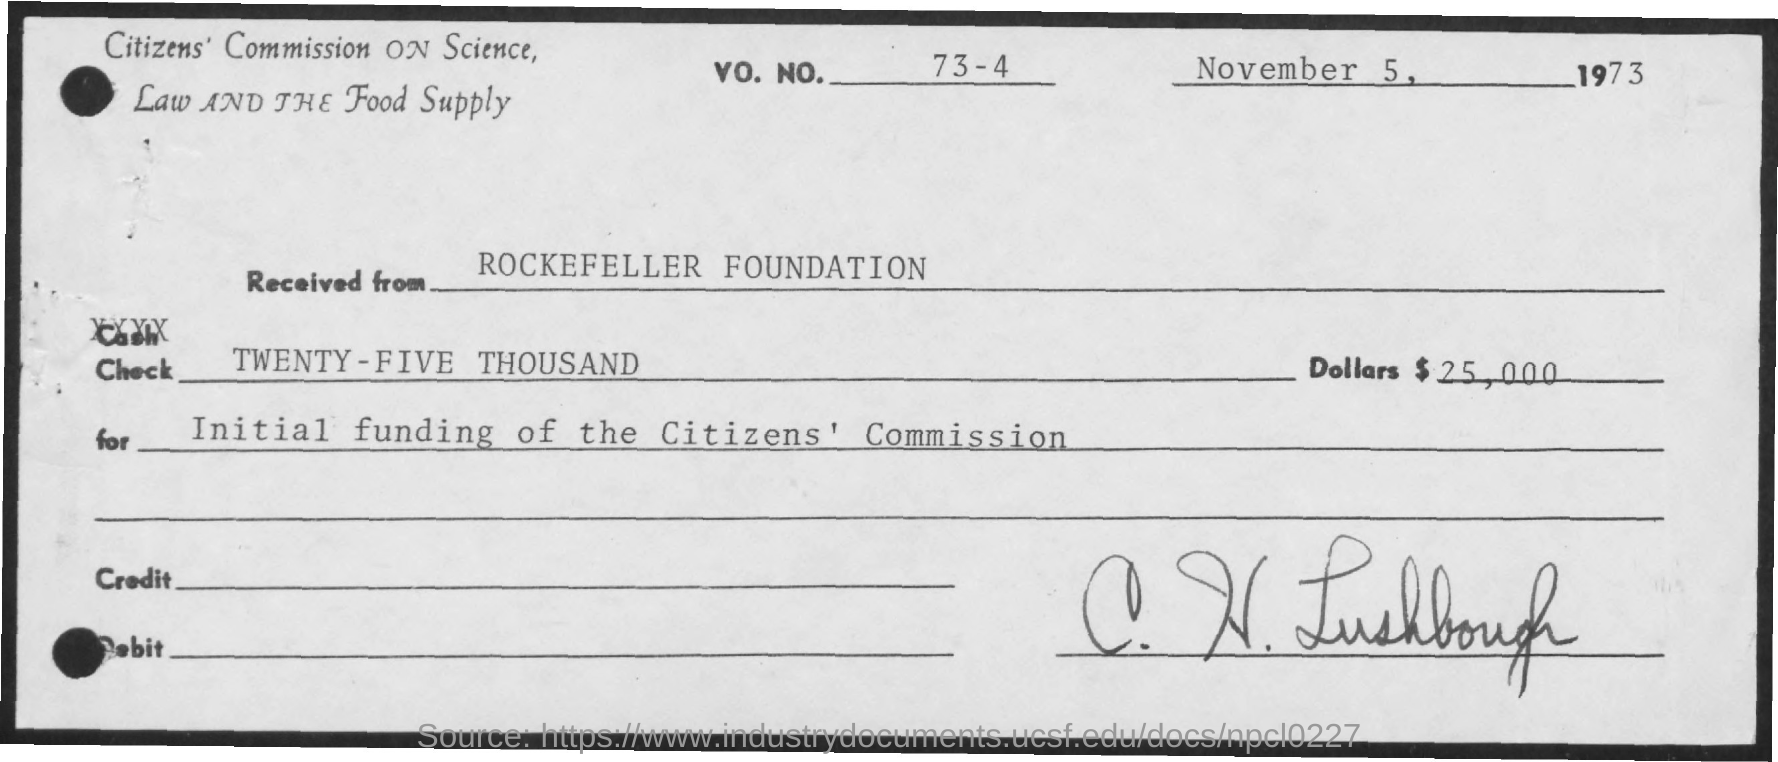Draw attention to some important aspects in this diagram. What is the phone number mentioned? It is 73-4. The date mentioned on the check is November 5, 1973. The purpose of this check is to fund the initial establishment of the citizen's commission. The check was received from the Rockefeller Foundation. The check shows an amount of $25,000. 